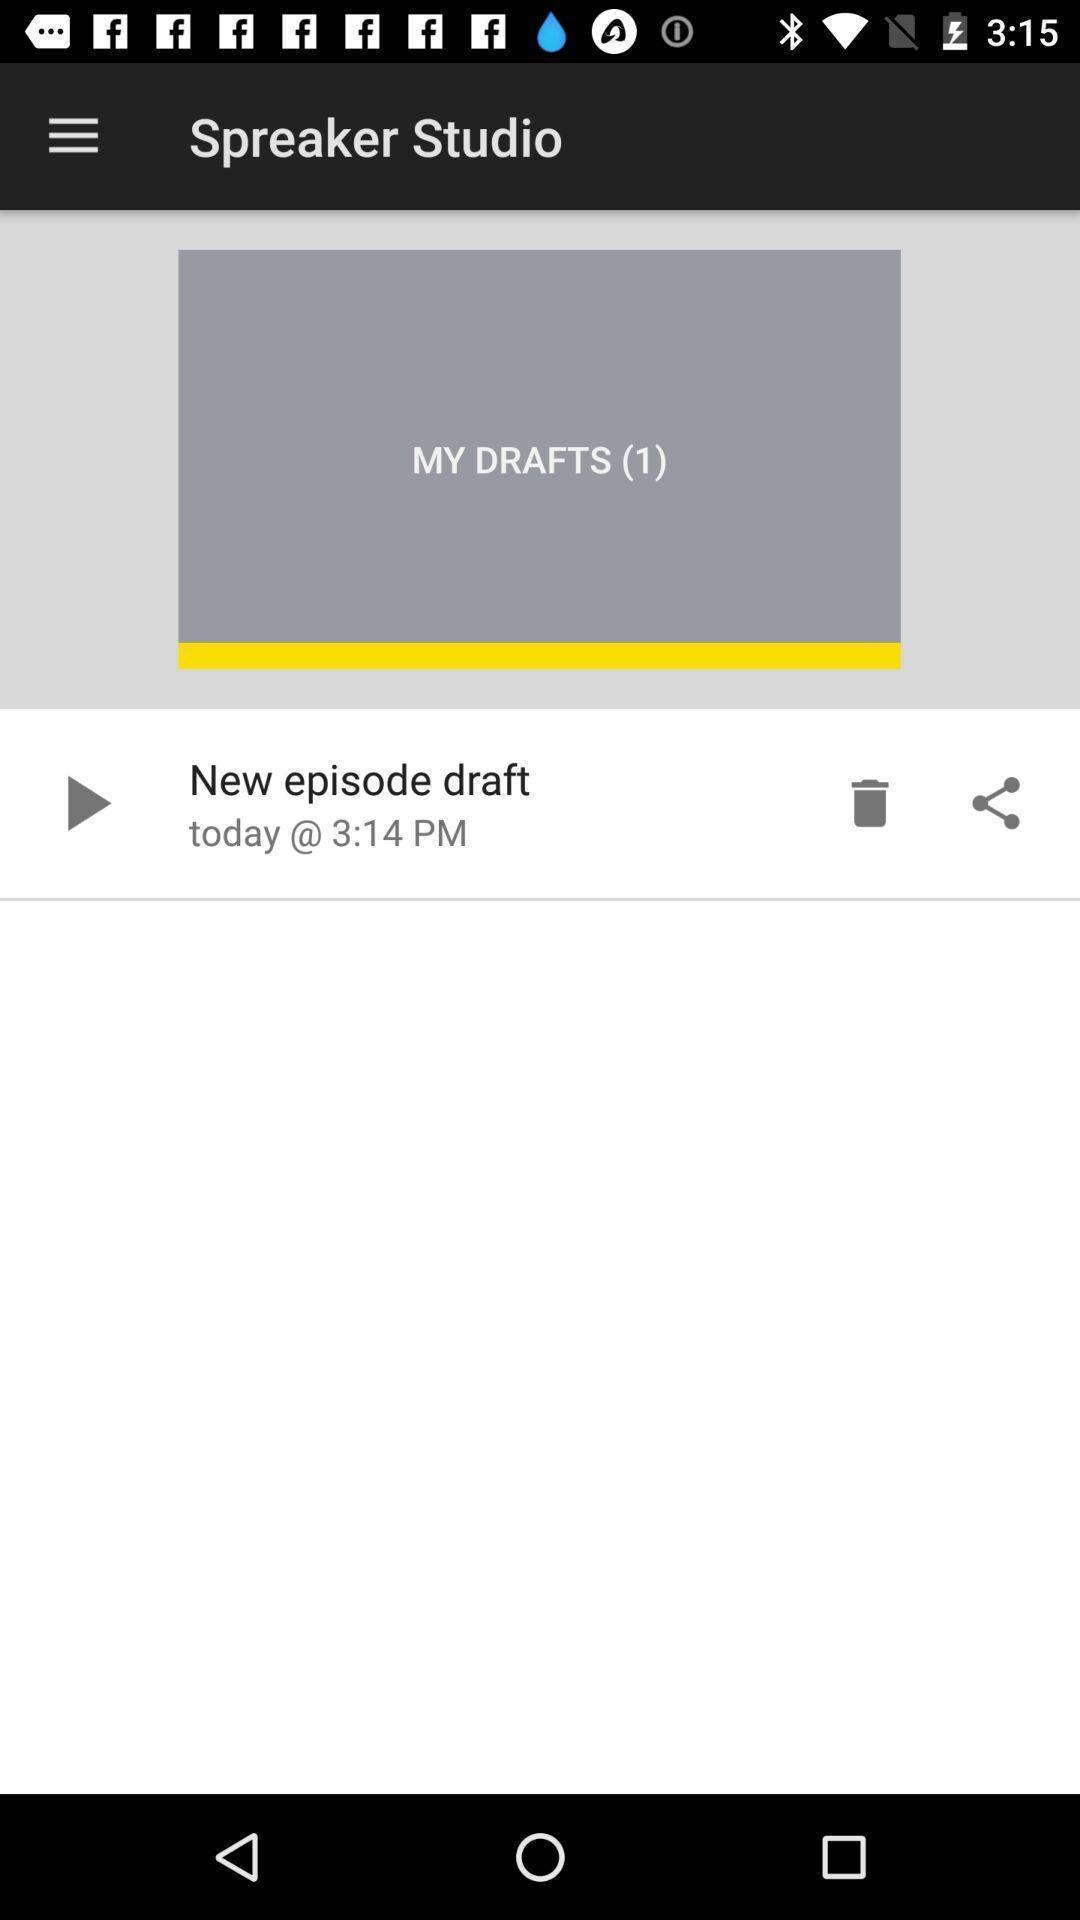Provide a textual representation of this image. Screen displaying multiple controls of a podcast application. 